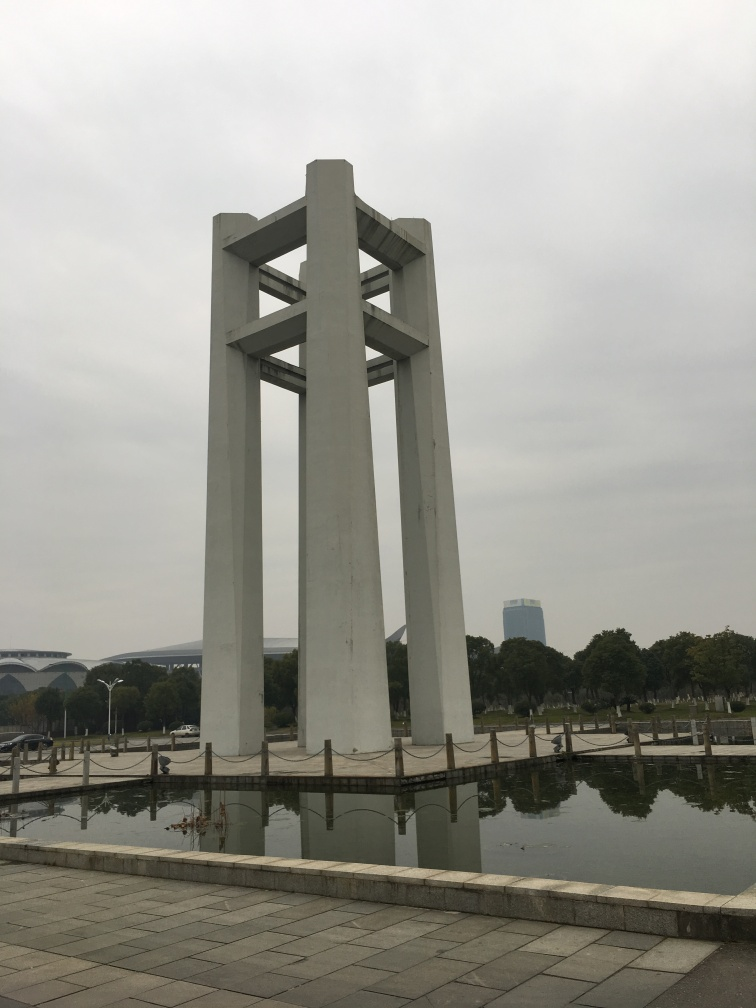This structure looks unique. What might be its purpose or significance? The towering structure in the image seems modern and could be a public art installation or a commemorative monument. Its location in an open space, likely a park or plaza, adds to its prominence, inviting visitors to reflect on its aesthetic or historical significance. 